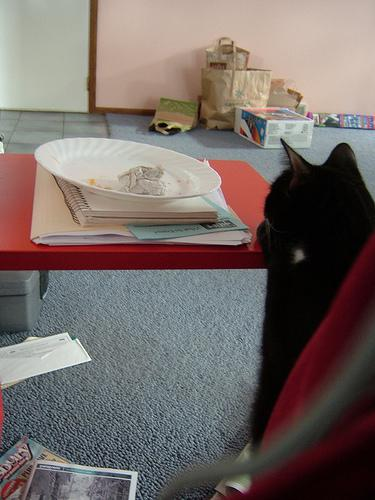Question: where was this photo taken?
Choices:
A. Living room.
B. Kitchen.
C. Bedroom.
D. Bathroom.
Answer with the letter. Answer: A Question: what is present?
Choices:
A. A dog.
B. A cat.
C. A bird.
D. A squirrel.
Answer with the letter. Answer: B 